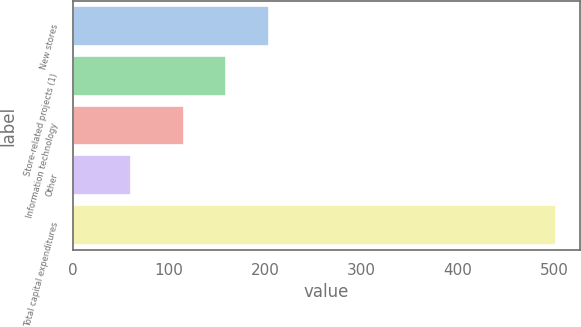<chart> <loc_0><loc_0><loc_500><loc_500><bar_chart><fcel>New stores<fcel>Store-related projects (1)<fcel>Information technology<fcel>Other<fcel>Total capital expenditures<nl><fcel>203.4<fcel>159.2<fcel>115<fcel>60<fcel>502<nl></chart> 